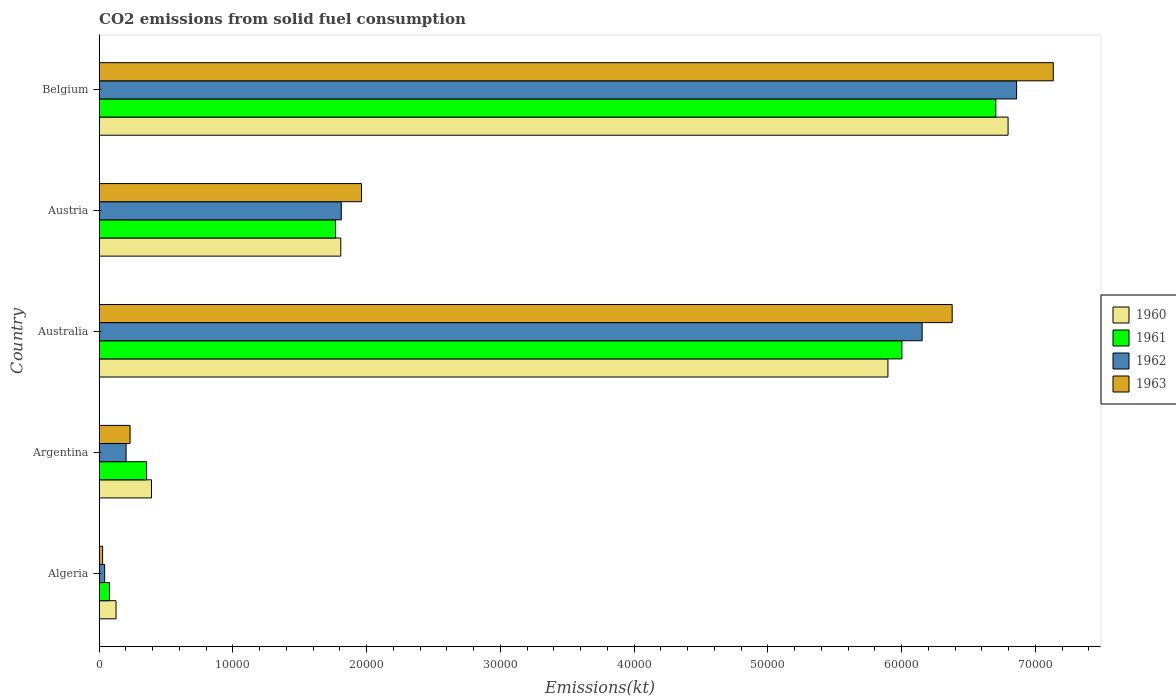How many groups of bars are there?
Make the answer very short. 5. Are the number of bars per tick equal to the number of legend labels?
Offer a terse response. Yes. How many bars are there on the 2nd tick from the top?
Make the answer very short. 4. How many bars are there on the 5th tick from the bottom?
Offer a very short reply. 4. What is the label of the 1st group of bars from the top?
Keep it short and to the point. Belgium. In how many cases, is the number of bars for a given country not equal to the number of legend labels?
Keep it short and to the point. 0. What is the amount of CO2 emitted in 1962 in Algeria?
Your response must be concise. 407.04. Across all countries, what is the maximum amount of CO2 emitted in 1960?
Make the answer very short. 6.80e+04. Across all countries, what is the minimum amount of CO2 emitted in 1961?
Provide a short and direct response. 766.4. In which country was the amount of CO2 emitted in 1961 maximum?
Your answer should be very brief. Belgium. In which country was the amount of CO2 emitted in 1963 minimum?
Provide a succinct answer. Algeria. What is the total amount of CO2 emitted in 1962 in the graph?
Offer a terse response. 1.51e+05. What is the difference between the amount of CO2 emitted in 1961 in Australia and that in Belgium?
Your answer should be compact. -7022.31. What is the difference between the amount of CO2 emitted in 1960 in Australia and the amount of CO2 emitted in 1962 in Belgium?
Keep it short and to the point. -9622.21. What is the average amount of CO2 emitted in 1963 per country?
Offer a terse response. 3.15e+04. What is the difference between the amount of CO2 emitted in 1963 and amount of CO2 emitted in 1960 in Argentina?
Your answer should be compact. -1602.48. What is the ratio of the amount of CO2 emitted in 1961 in Australia to that in Austria?
Your answer should be very brief. 3.4. What is the difference between the highest and the second highest amount of CO2 emitted in 1963?
Provide a short and direct response. 7561.35. What is the difference between the highest and the lowest amount of CO2 emitted in 1961?
Your answer should be very brief. 6.63e+04. In how many countries, is the amount of CO2 emitted in 1961 greater than the average amount of CO2 emitted in 1961 taken over all countries?
Provide a succinct answer. 2. Is the sum of the amount of CO2 emitted in 1962 in Argentina and Australia greater than the maximum amount of CO2 emitted in 1960 across all countries?
Provide a short and direct response. No. What does the 1st bar from the bottom in Argentina represents?
Offer a very short reply. 1960. Is it the case that in every country, the sum of the amount of CO2 emitted in 1963 and amount of CO2 emitted in 1961 is greater than the amount of CO2 emitted in 1962?
Keep it short and to the point. Yes. How many bars are there?
Your answer should be very brief. 20. Are all the bars in the graph horizontal?
Provide a short and direct response. Yes. What is the difference between two consecutive major ticks on the X-axis?
Keep it short and to the point. 10000. Are the values on the major ticks of X-axis written in scientific E-notation?
Provide a short and direct response. No. Does the graph contain any zero values?
Your response must be concise. No. Where does the legend appear in the graph?
Offer a very short reply. Center right. How many legend labels are there?
Ensure brevity in your answer.  4. How are the legend labels stacked?
Your response must be concise. Vertical. What is the title of the graph?
Provide a short and direct response. CO2 emissions from solid fuel consumption. What is the label or title of the X-axis?
Ensure brevity in your answer.  Emissions(kt). What is the Emissions(kt) of 1960 in Algeria?
Provide a succinct answer. 1257.78. What is the Emissions(kt) in 1961 in Algeria?
Keep it short and to the point. 766.4. What is the Emissions(kt) in 1962 in Algeria?
Your answer should be compact. 407.04. What is the Emissions(kt) in 1963 in Algeria?
Give a very brief answer. 253.02. What is the Emissions(kt) of 1960 in Argentina?
Provide a short and direct response. 3909.02. What is the Emissions(kt) in 1961 in Argentina?
Your answer should be very brief. 3542.32. What is the Emissions(kt) in 1962 in Argentina?
Provide a succinct answer. 2009.52. What is the Emissions(kt) of 1963 in Argentina?
Your answer should be very brief. 2306.54. What is the Emissions(kt) in 1960 in Australia?
Keep it short and to the point. 5.90e+04. What is the Emissions(kt) in 1961 in Australia?
Ensure brevity in your answer.  6.00e+04. What is the Emissions(kt) in 1962 in Australia?
Your response must be concise. 6.15e+04. What is the Emissions(kt) in 1963 in Australia?
Ensure brevity in your answer.  6.38e+04. What is the Emissions(kt) in 1960 in Austria?
Your response must be concise. 1.81e+04. What is the Emissions(kt) of 1961 in Austria?
Keep it short and to the point. 1.77e+04. What is the Emissions(kt) of 1962 in Austria?
Offer a terse response. 1.81e+04. What is the Emissions(kt) of 1963 in Austria?
Ensure brevity in your answer.  1.96e+04. What is the Emissions(kt) of 1960 in Belgium?
Your answer should be compact. 6.80e+04. What is the Emissions(kt) in 1961 in Belgium?
Your response must be concise. 6.70e+04. What is the Emissions(kt) of 1962 in Belgium?
Offer a terse response. 6.86e+04. What is the Emissions(kt) of 1963 in Belgium?
Your answer should be very brief. 7.13e+04. Across all countries, what is the maximum Emissions(kt) in 1960?
Keep it short and to the point. 6.80e+04. Across all countries, what is the maximum Emissions(kt) in 1961?
Offer a terse response. 6.70e+04. Across all countries, what is the maximum Emissions(kt) of 1962?
Provide a short and direct response. 6.86e+04. Across all countries, what is the maximum Emissions(kt) of 1963?
Your answer should be compact. 7.13e+04. Across all countries, what is the minimum Emissions(kt) of 1960?
Your answer should be compact. 1257.78. Across all countries, what is the minimum Emissions(kt) of 1961?
Ensure brevity in your answer.  766.4. Across all countries, what is the minimum Emissions(kt) in 1962?
Ensure brevity in your answer.  407.04. Across all countries, what is the minimum Emissions(kt) in 1963?
Make the answer very short. 253.02. What is the total Emissions(kt) of 1960 in the graph?
Provide a succinct answer. 1.50e+05. What is the total Emissions(kt) of 1961 in the graph?
Offer a terse response. 1.49e+05. What is the total Emissions(kt) in 1962 in the graph?
Ensure brevity in your answer.  1.51e+05. What is the total Emissions(kt) in 1963 in the graph?
Offer a very short reply. 1.57e+05. What is the difference between the Emissions(kt) in 1960 in Algeria and that in Argentina?
Offer a very short reply. -2651.24. What is the difference between the Emissions(kt) in 1961 in Algeria and that in Argentina?
Give a very brief answer. -2775.92. What is the difference between the Emissions(kt) in 1962 in Algeria and that in Argentina?
Offer a very short reply. -1602.48. What is the difference between the Emissions(kt) in 1963 in Algeria and that in Argentina?
Keep it short and to the point. -2053.52. What is the difference between the Emissions(kt) of 1960 in Algeria and that in Australia?
Keep it short and to the point. -5.77e+04. What is the difference between the Emissions(kt) in 1961 in Algeria and that in Australia?
Provide a succinct answer. -5.93e+04. What is the difference between the Emissions(kt) in 1962 in Algeria and that in Australia?
Your response must be concise. -6.11e+04. What is the difference between the Emissions(kt) of 1963 in Algeria and that in Australia?
Your answer should be very brief. -6.35e+04. What is the difference between the Emissions(kt) of 1960 in Algeria and that in Austria?
Offer a terse response. -1.68e+04. What is the difference between the Emissions(kt) of 1961 in Algeria and that in Austria?
Your answer should be compact. -1.69e+04. What is the difference between the Emissions(kt) in 1962 in Algeria and that in Austria?
Your response must be concise. -1.77e+04. What is the difference between the Emissions(kt) of 1963 in Algeria and that in Austria?
Make the answer very short. -1.94e+04. What is the difference between the Emissions(kt) of 1960 in Algeria and that in Belgium?
Offer a very short reply. -6.67e+04. What is the difference between the Emissions(kt) in 1961 in Algeria and that in Belgium?
Offer a terse response. -6.63e+04. What is the difference between the Emissions(kt) in 1962 in Algeria and that in Belgium?
Your answer should be compact. -6.82e+04. What is the difference between the Emissions(kt) of 1963 in Algeria and that in Belgium?
Offer a terse response. -7.11e+04. What is the difference between the Emissions(kt) in 1960 in Argentina and that in Australia?
Give a very brief answer. -5.51e+04. What is the difference between the Emissions(kt) of 1961 in Argentina and that in Australia?
Offer a very short reply. -5.65e+04. What is the difference between the Emissions(kt) in 1962 in Argentina and that in Australia?
Your answer should be compact. -5.95e+04. What is the difference between the Emissions(kt) of 1963 in Argentina and that in Australia?
Keep it short and to the point. -6.15e+04. What is the difference between the Emissions(kt) in 1960 in Argentina and that in Austria?
Provide a succinct answer. -1.42e+04. What is the difference between the Emissions(kt) of 1961 in Argentina and that in Austria?
Offer a very short reply. -1.41e+04. What is the difference between the Emissions(kt) of 1962 in Argentina and that in Austria?
Provide a succinct answer. -1.61e+04. What is the difference between the Emissions(kt) in 1963 in Argentina and that in Austria?
Offer a terse response. -1.73e+04. What is the difference between the Emissions(kt) of 1960 in Argentina and that in Belgium?
Make the answer very short. -6.41e+04. What is the difference between the Emissions(kt) in 1961 in Argentina and that in Belgium?
Offer a terse response. -6.35e+04. What is the difference between the Emissions(kt) of 1962 in Argentina and that in Belgium?
Offer a very short reply. -6.66e+04. What is the difference between the Emissions(kt) of 1963 in Argentina and that in Belgium?
Your answer should be compact. -6.90e+04. What is the difference between the Emissions(kt) of 1960 in Australia and that in Austria?
Your answer should be very brief. 4.09e+04. What is the difference between the Emissions(kt) of 1961 in Australia and that in Austria?
Ensure brevity in your answer.  4.23e+04. What is the difference between the Emissions(kt) of 1962 in Australia and that in Austria?
Your answer should be compact. 4.34e+04. What is the difference between the Emissions(kt) of 1963 in Australia and that in Austria?
Offer a terse response. 4.42e+04. What is the difference between the Emissions(kt) in 1960 in Australia and that in Belgium?
Your response must be concise. -8984.15. What is the difference between the Emissions(kt) of 1961 in Australia and that in Belgium?
Keep it short and to the point. -7022.31. What is the difference between the Emissions(kt) in 1962 in Australia and that in Belgium?
Provide a short and direct response. -7062.64. What is the difference between the Emissions(kt) of 1963 in Australia and that in Belgium?
Keep it short and to the point. -7561.35. What is the difference between the Emissions(kt) of 1960 in Austria and that in Belgium?
Give a very brief answer. -4.99e+04. What is the difference between the Emissions(kt) of 1961 in Austria and that in Belgium?
Offer a terse response. -4.94e+04. What is the difference between the Emissions(kt) in 1962 in Austria and that in Belgium?
Your answer should be compact. -5.05e+04. What is the difference between the Emissions(kt) of 1963 in Austria and that in Belgium?
Give a very brief answer. -5.17e+04. What is the difference between the Emissions(kt) in 1960 in Algeria and the Emissions(kt) in 1961 in Argentina?
Offer a very short reply. -2284.54. What is the difference between the Emissions(kt) of 1960 in Algeria and the Emissions(kt) of 1962 in Argentina?
Offer a terse response. -751.74. What is the difference between the Emissions(kt) in 1960 in Algeria and the Emissions(kt) in 1963 in Argentina?
Ensure brevity in your answer.  -1048.76. What is the difference between the Emissions(kt) in 1961 in Algeria and the Emissions(kt) in 1962 in Argentina?
Make the answer very short. -1243.11. What is the difference between the Emissions(kt) of 1961 in Algeria and the Emissions(kt) of 1963 in Argentina?
Provide a succinct answer. -1540.14. What is the difference between the Emissions(kt) of 1962 in Algeria and the Emissions(kt) of 1963 in Argentina?
Offer a very short reply. -1899.51. What is the difference between the Emissions(kt) of 1960 in Algeria and the Emissions(kt) of 1961 in Australia?
Give a very brief answer. -5.88e+04. What is the difference between the Emissions(kt) in 1960 in Algeria and the Emissions(kt) in 1962 in Australia?
Offer a very short reply. -6.03e+04. What is the difference between the Emissions(kt) in 1960 in Algeria and the Emissions(kt) in 1963 in Australia?
Make the answer very short. -6.25e+04. What is the difference between the Emissions(kt) of 1961 in Algeria and the Emissions(kt) of 1962 in Australia?
Offer a terse response. -6.08e+04. What is the difference between the Emissions(kt) of 1961 in Algeria and the Emissions(kt) of 1963 in Australia?
Ensure brevity in your answer.  -6.30e+04. What is the difference between the Emissions(kt) of 1962 in Algeria and the Emissions(kt) of 1963 in Australia?
Ensure brevity in your answer.  -6.34e+04. What is the difference between the Emissions(kt) in 1960 in Algeria and the Emissions(kt) in 1961 in Austria?
Offer a very short reply. -1.64e+04. What is the difference between the Emissions(kt) in 1960 in Algeria and the Emissions(kt) in 1962 in Austria?
Your answer should be very brief. -1.68e+04. What is the difference between the Emissions(kt) of 1960 in Algeria and the Emissions(kt) of 1963 in Austria?
Your answer should be very brief. -1.84e+04. What is the difference between the Emissions(kt) of 1961 in Algeria and the Emissions(kt) of 1962 in Austria?
Make the answer very short. -1.73e+04. What is the difference between the Emissions(kt) in 1961 in Algeria and the Emissions(kt) in 1963 in Austria?
Give a very brief answer. -1.88e+04. What is the difference between the Emissions(kt) of 1962 in Algeria and the Emissions(kt) of 1963 in Austria?
Make the answer very short. -1.92e+04. What is the difference between the Emissions(kt) in 1960 in Algeria and the Emissions(kt) in 1961 in Belgium?
Offer a terse response. -6.58e+04. What is the difference between the Emissions(kt) of 1960 in Algeria and the Emissions(kt) of 1962 in Belgium?
Offer a very short reply. -6.73e+04. What is the difference between the Emissions(kt) of 1960 in Algeria and the Emissions(kt) of 1963 in Belgium?
Make the answer very short. -7.01e+04. What is the difference between the Emissions(kt) in 1961 in Algeria and the Emissions(kt) in 1962 in Belgium?
Your response must be concise. -6.78e+04. What is the difference between the Emissions(kt) in 1961 in Algeria and the Emissions(kt) in 1963 in Belgium?
Make the answer very short. -7.06e+04. What is the difference between the Emissions(kt) in 1962 in Algeria and the Emissions(kt) in 1963 in Belgium?
Ensure brevity in your answer.  -7.09e+04. What is the difference between the Emissions(kt) in 1960 in Argentina and the Emissions(kt) in 1961 in Australia?
Offer a terse response. -5.61e+04. What is the difference between the Emissions(kt) in 1960 in Argentina and the Emissions(kt) in 1962 in Australia?
Give a very brief answer. -5.76e+04. What is the difference between the Emissions(kt) in 1960 in Argentina and the Emissions(kt) in 1963 in Australia?
Offer a terse response. -5.99e+04. What is the difference between the Emissions(kt) of 1961 in Argentina and the Emissions(kt) of 1962 in Australia?
Your answer should be compact. -5.80e+04. What is the difference between the Emissions(kt) in 1961 in Argentina and the Emissions(kt) in 1963 in Australia?
Give a very brief answer. -6.02e+04. What is the difference between the Emissions(kt) in 1962 in Argentina and the Emissions(kt) in 1963 in Australia?
Provide a short and direct response. -6.18e+04. What is the difference between the Emissions(kt) of 1960 in Argentina and the Emissions(kt) of 1961 in Austria?
Offer a very short reply. -1.38e+04. What is the difference between the Emissions(kt) in 1960 in Argentina and the Emissions(kt) in 1962 in Austria?
Offer a terse response. -1.42e+04. What is the difference between the Emissions(kt) of 1960 in Argentina and the Emissions(kt) of 1963 in Austria?
Keep it short and to the point. -1.57e+04. What is the difference between the Emissions(kt) of 1961 in Argentina and the Emissions(kt) of 1962 in Austria?
Offer a very short reply. -1.46e+04. What is the difference between the Emissions(kt) in 1961 in Argentina and the Emissions(kt) in 1963 in Austria?
Make the answer very short. -1.61e+04. What is the difference between the Emissions(kt) in 1962 in Argentina and the Emissions(kt) in 1963 in Austria?
Keep it short and to the point. -1.76e+04. What is the difference between the Emissions(kt) of 1960 in Argentina and the Emissions(kt) of 1961 in Belgium?
Your answer should be compact. -6.31e+04. What is the difference between the Emissions(kt) in 1960 in Argentina and the Emissions(kt) in 1962 in Belgium?
Your answer should be very brief. -6.47e+04. What is the difference between the Emissions(kt) in 1960 in Argentina and the Emissions(kt) in 1963 in Belgium?
Provide a succinct answer. -6.74e+04. What is the difference between the Emissions(kt) in 1961 in Argentina and the Emissions(kt) in 1962 in Belgium?
Ensure brevity in your answer.  -6.51e+04. What is the difference between the Emissions(kt) of 1961 in Argentina and the Emissions(kt) of 1963 in Belgium?
Your answer should be compact. -6.78e+04. What is the difference between the Emissions(kt) of 1962 in Argentina and the Emissions(kt) of 1963 in Belgium?
Keep it short and to the point. -6.93e+04. What is the difference between the Emissions(kt) of 1960 in Australia and the Emissions(kt) of 1961 in Austria?
Offer a very short reply. 4.13e+04. What is the difference between the Emissions(kt) in 1960 in Australia and the Emissions(kt) in 1962 in Austria?
Offer a very short reply. 4.09e+04. What is the difference between the Emissions(kt) in 1960 in Australia and the Emissions(kt) in 1963 in Austria?
Your response must be concise. 3.94e+04. What is the difference between the Emissions(kt) in 1961 in Australia and the Emissions(kt) in 1962 in Austria?
Make the answer very short. 4.19e+04. What is the difference between the Emissions(kt) of 1961 in Australia and the Emissions(kt) of 1963 in Austria?
Offer a terse response. 4.04e+04. What is the difference between the Emissions(kt) of 1962 in Australia and the Emissions(kt) of 1963 in Austria?
Ensure brevity in your answer.  4.19e+04. What is the difference between the Emissions(kt) in 1960 in Australia and the Emissions(kt) in 1961 in Belgium?
Your answer should be very brief. -8067.4. What is the difference between the Emissions(kt) in 1960 in Australia and the Emissions(kt) in 1962 in Belgium?
Provide a succinct answer. -9622.21. What is the difference between the Emissions(kt) in 1960 in Australia and the Emissions(kt) in 1963 in Belgium?
Provide a succinct answer. -1.24e+04. What is the difference between the Emissions(kt) of 1961 in Australia and the Emissions(kt) of 1962 in Belgium?
Provide a succinct answer. -8577.11. What is the difference between the Emissions(kt) in 1961 in Australia and the Emissions(kt) in 1963 in Belgium?
Offer a terse response. -1.13e+04. What is the difference between the Emissions(kt) in 1962 in Australia and the Emissions(kt) in 1963 in Belgium?
Your answer should be compact. -9805.56. What is the difference between the Emissions(kt) of 1960 in Austria and the Emissions(kt) of 1961 in Belgium?
Make the answer very short. -4.90e+04. What is the difference between the Emissions(kt) of 1960 in Austria and the Emissions(kt) of 1962 in Belgium?
Give a very brief answer. -5.05e+04. What is the difference between the Emissions(kt) in 1960 in Austria and the Emissions(kt) in 1963 in Belgium?
Keep it short and to the point. -5.33e+04. What is the difference between the Emissions(kt) in 1961 in Austria and the Emissions(kt) in 1962 in Belgium?
Provide a succinct answer. -5.09e+04. What is the difference between the Emissions(kt) of 1961 in Austria and the Emissions(kt) of 1963 in Belgium?
Ensure brevity in your answer.  -5.37e+04. What is the difference between the Emissions(kt) in 1962 in Austria and the Emissions(kt) in 1963 in Belgium?
Your response must be concise. -5.32e+04. What is the average Emissions(kt) of 1960 per country?
Give a very brief answer. 3.00e+04. What is the average Emissions(kt) of 1961 per country?
Your response must be concise. 2.98e+04. What is the average Emissions(kt) of 1962 per country?
Offer a terse response. 3.01e+04. What is the average Emissions(kt) in 1963 per country?
Your response must be concise. 3.15e+04. What is the difference between the Emissions(kt) of 1960 and Emissions(kt) of 1961 in Algeria?
Provide a short and direct response. 491.38. What is the difference between the Emissions(kt) of 1960 and Emissions(kt) of 1962 in Algeria?
Your answer should be very brief. 850.74. What is the difference between the Emissions(kt) of 1960 and Emissions(kt) of 1963 in Algeria?
Provide a succinct answer. 1004.76. What is the difference between the Emissions(kt) of 1961 and Emissions(kt) of 1962 in Algeria?
Your answer should be compact. 359.37. What is the difference between the Emissions(kt) in 1961 and Emissions(kt) in 1963 in Algeria?
Your answer should be very brief. 513.38. What is the difference between the Emissions(kt) in 1962 and Emissions(kt) in 1963 in Algeria?
Ensure brevity in your answer.  154.01. What is the difference between the Emissions(kt) of 1960 and Emissions(kt) of 1961 in Argentina?
Keep it short and to the point. 366.7. What is the difference between the Emissions(kt) of 1960 and Emissions(kt) of 1962 in Argentina?
Offer a terse response. 1899.51. What is the difference between the Emissions(kt) in 1960 and Emissions(kt) in 1963 in Argentina?
Your answer should be compact. 1602.48. What is the difference between the Emissions(kt) of 1961 and Emissions(kt) of 1962 in Argentina?
Your answer should be compact. 1532.81. What is the difference between the Emissions(kt) of 1961 and Emissions(kt) of 1963 in Argentina?
Ensure brevity in your answer.  1235.78. What is the difference between the Emissions(kt) in 1962 and Emissions(kt) in 1963 in Argentina?
Give a very brief answer. -297.03. What is the difference between the Emissions(kt) of 1960 and Emissions(kt) of 1961 in Australia?
Keep it short and to the point. -1045.1. What is the difference between the Emissions(kt) of 1960 and Emissions(kt) of 1962 in Australia?
Keep it short and to the point. -2559.57. What is the difference between the Emissions(kt) of 1960 and Emissions(kt) of 1963 in Australia?
Offer a terse response. -4803.77. What is the difference between the Emissions(kt) of 1961 and Emissions(kt) of 1962 in Australia?
Your answer should be compact. -1514.47. What is the difference between the Emissions(kt) of 1961 and Emissions(kt) of 1963 in Australia?
Offer a very short reply. -3758.68. What is the difference between the Emissions(kt) in 1962 and Emissions(kt) in 1963 in Australia?
Offer a terse response. -2244.2. What is the difference between the Emissions(kt) in 1960 and Emissions(kt) in 1961 in Austria?
Make the answer very short. 388.7. What is the difference between the Emissions(kt) of 1960 and Emissions(kt) of 1962 in Austria?
Give a very brief answer. -36.67. What is the difference between the Emissions(kt) in 1960 and Emissions(kt) in 1963 in Austria?
Make the answer very short. -1551.14. What is the difference between the Emissions(kt) in 1961 and Emissions(kt) in 1962 in Austria?
Keep it short and to the point. -425.37. What is the difference between the Emissions(kt) of 1961 and Emissions(kt) of 1963 in Austria?
Provide a succinct answer. -1939.84. What is the difference between the Emissions(kt) of 1962 and Emissions(kt) of 1963 in Austria?
Offer a terse response. -1514.47. What is the difference between the Emissions(kt) in 1960 and Emissions(kt) in 1961 in Belgium?
Offer a terse response. 916.75. What is the difference between the Emissions(kt) in 1960 and Emissions(kt) in 1962 in Belgium?
Ensure brevity in your answer.  -638.06. What is the difference between the Emissions(kt) in 1960 and Emissions(kt) in 1963 in Belgium?
Your answer should be very brief. -3380.97. What is the difference between the Emissions(kt) of 1961 and Emissions(kt) of 1962 in Belgium?
Keep it short and to the point. -1554.81. What is the difference between the Emissions(kt) of 1961 and Emissions(kt) of 1963 in Belgium?
Your answer should be very brief. -4297.72. What is the difference between the Emissions(kt) of 1962 and Emissions(kt) of 1963 in Belgium?
Offer a terse response. -2742.92. What is the ratio of the Emissions(kt) in 1960 in Algeria to that in Argentina?
Provide a short and direct response. 0.32. What is the ratio of the Emissions(kt) in 1961 in Algeria to that in Argentina?
Provide a succinct answer. 0.22. What is the ratio of the Emissions(kt) in 1962 in Algeria to that in Argentina?
Provide a succinct answer. 0.2. What is the ratio of the Emissions(kt) of 1963 in Algeria to that in Argentina?
Keep it short and to the point. 0.11. What is the ratio of the Emissions(kt) in 1960 in Algeria to that in Australia?
Your answer should be compact. 0.02. What is the ratio of the Emissions(kt) of 1961 in Algeria to that in Australia?
Offer a very short reply. 0.01. What is the ratio of the Emissions(kt) in 1962 in Algeria to that in Australia?
Provide a succinct answer. 0.01. What is the ratio of the Emissions(kt) of 1963 in Algeria to that in Australia?
Provide a short and direct response. 0. What is the ratio of the Emissions(kt) of 1960 in Algeria to that in Austria?
Your answer should be compact. 0.07. What is the ratio of the Emissions(kt) in 1961 in Algeria to that in Austria?
Provide a succinct answer. 0.04. What is the ratio of the Emissions(kt) in 1962 in Algeria to that in Austria?
Your answer should be very brief. 0.02. What is the ratio of the Emissions(kt) in 1963 in Algeria to that in Austria?
Make the answer very short. 0.01. What is the ratio of the Emissions(kt) in 1960 in Algeria to that in Belgium?
Provide a succinct answer. 0.02. What is the ratio of the Emissions(kt) of 1961 in Algeria to that in Belgium?
Make the answer very short. 0.01. What is the ratio of the Emissions(kt) of 1962 in Algeria to that in Belgium?
Ensure brevity in your answer.  0.01. What is the ratio of the Emissions(kt) of 1963 in Algeria to that in Belgium?
Your response must be concise. 0. What is the ratio of the Emissions(kt) in 1960 in Argentina to that in Australia?
Give a very brief answer. 0.07. What is the ratio of the Emissions(kt) of 1961 in Argentina to that in Australia?
Ensure brevity in your answer.  0.06. What is the ratio of the Emissions(kt) in 1962 in Argentina to that in Australia?
Give a very brief answer. 0.03. What is the ratio of the Emissions(kt) of 1963 in Argentina to that in Australia?
Ensure brevity in your answer.  0.04. What is the ratio of the Emissions(kt) of 1960 in Argentina to that in Austria?
Provide a succinct answer. 0.22. What is the ratio of the Emissions(kt) of 1961 in Argentina to that in Austria?
Offer a very short reply. 0.2. What is the ratio of the Emissions(kt) of 1962 in Argentina to that in Austria?
Your response must be concise. 0.11. What is the ratio of the Emissions(kt) in 1963 in Argentina to that in Austria?
Make the answer very short. 0.12. What is the ratio of the Emissions(kt) in 1960 in Argentina to that in Belgium?
Keep it short and to the point. 0.06. What is the ratio of the Emissions(kt) in 1961 in Argentina to that in Belgium?
Provide a short and direct response. 0.05. What is the ratio of the Emissions(kt) in 1962 in Argentina to that in Belgium?
Offer a terse response. 0.03. What is the ratio of the Emissions(kt) of 1963 in Argentina to that in Belgium?
Give a very brief answer. 0.03. What is the ratio of the Emissions(kt) of 1960 in Australia to that in Austria?
Your answer should be compact. 3.26. What is the ratio of the Emissions(kt) in 1961 in Australia to that in Austria?
Keep it short and to the point. 3.4. What is the ratio of the Emissions(kt) of 1962 in Australia to that in Austria?
Provide a succinct answer. 3.4. What is the ratio of the Emissions(kt) in 1963 in Australia to that in Austria?
Your response must be concise. 3.25. What is the ratio of the Emissions(kt) of 1960 in Australia to that in Belgium?
Provide a short and direct response. 0.87. What is the ratio of the Emissions(kt) of 1961 in Australia to that in Belgium?
Make the answer very short. 0.9. What is the ratio of the Emissions(kt) in 1962 in Australia to that in Belgium?
Offer a terse response. 0.9. What is the ratio of the Emissions(kt) of 1963 in Australia to that in Belgium?
Ensure brevity in your answer.  0.89. What is the ratio of the Emissions(kt) in 1960 in Austria to that in Belgium?
Your answer should be compact. 0.27. What is the ratio of the Emissions(kt) in 1961 in Austria to that in Belgium?
Keep it short and to the point. 0.26. What is the ratio of the Emissions(kt) in 1962 in Austria to that in Belgium?
Your response must be concise. 0.26. What is the ratio of the Emissions(kt) of 1963 in Austria to that in Belgium?
Your answer should be compact. 0.27. What is the difference between the highest and the second highest Emissions(kt) of 1960?
Your answer should be very brief. 8984.15. What is the difference between the highest and the second highest Emissions(kt) in 1961?
Provide a succinct answer. 7022.31. What is the difference between the highest and the second highest Emissions(kt) of 1962?
Offer a very short reply. 7062.64. What is the difference between the highest and the second highest Emissions(kt) of 1963?
Make the answer very short. 7561.35. What is the difference between the highest and the lowest Emissions(kt) of 1960?
Provide a succinct answer. 6.67e+04. What is the difference between the highest and the lowest Emissions(kt) in 1961?
Give a very brief answer. 6.63e+04. What is the difference between the highest and the lowest Emissions(kt) of 1962?
Your answer should be very brief. 6.82e+04. What is the difference between the highest and the lowest Emissions(kt) of 1963?
Your response must be concise. 7.11e+04. 